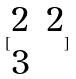Convert formula to latex. <formula><loc_0><loc_0><loc_500><loc_500>[ \begin{matrix} 2 & 2 \\ 3 \end{matrix} ]</formula> 